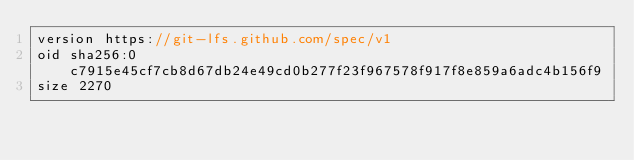Convert code to text. <code><loc_0><loc_0><loc_500><loc_500><_C_>version https://git-lfs.github.com/spec/v1
oid sha256:0c7915e45cf7cb8d67db24e49cd0b277f23f967578f917f8e859a6adc4b156f9
size 2270
</code> 